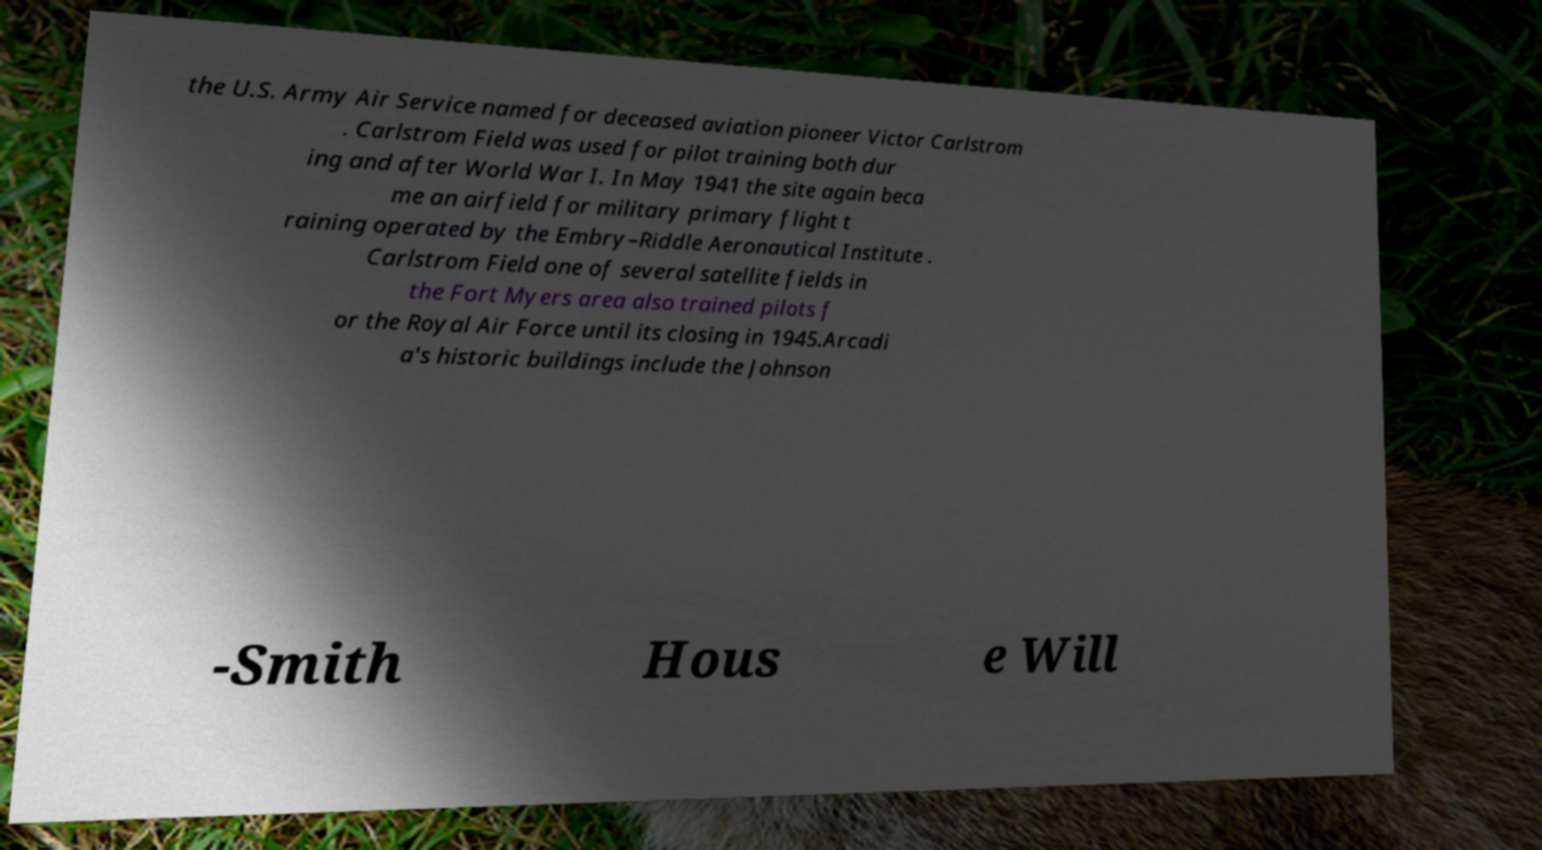Could you extract and type out the text from this image? the U.S. Army Air Service named for deceased aviation pioneer Victor Carlstrom . Carlstrom Field was used for pilot training both dur ing and after World War I. In May 1941 the site again beca me an airfield for military primary flight t raining operated by the Embry–Riddle Aeronautical Institute . Carlstrom Field one of several satellite fields in the Fort Myers area also trained pilots f or the Royal Air Force until its closing in 1945.Arcadi a's historic buildings include the Johnson -Smith Hous e Will 